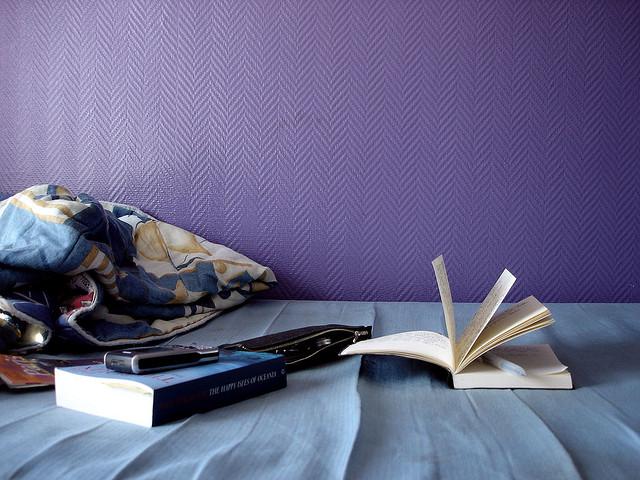What is in the book?
Quick response, please. Pen. Are these hardcover or softcover books?
Keep it brief. Softcover. What is "saving a page" for the reader?
Keep it brief. Pen. 